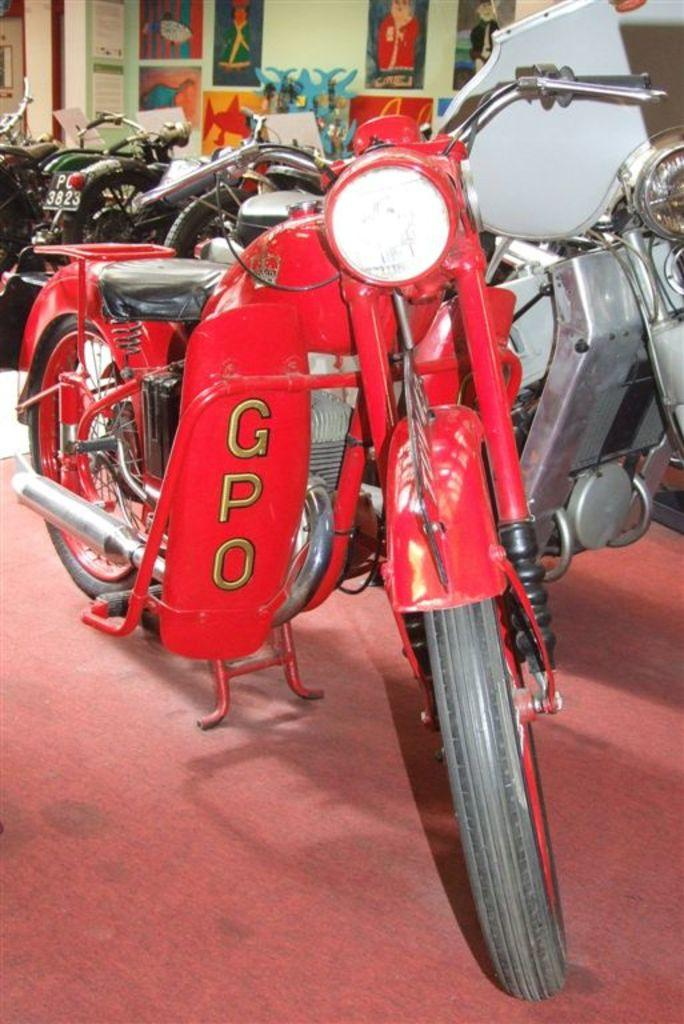What objects are on the floor in the image? There are two bikes on the floor. What can be seen in the background of the image? There are vehicles and bicycles in the background of the image. What is on the wall in the background of the image? There are posters on the wall in the background of the image. What type of underwear is hanging on the bicycle in the image? There is no underwear present in the image; it only features bikes, vehicles, bicycles, and posters on the wall. 